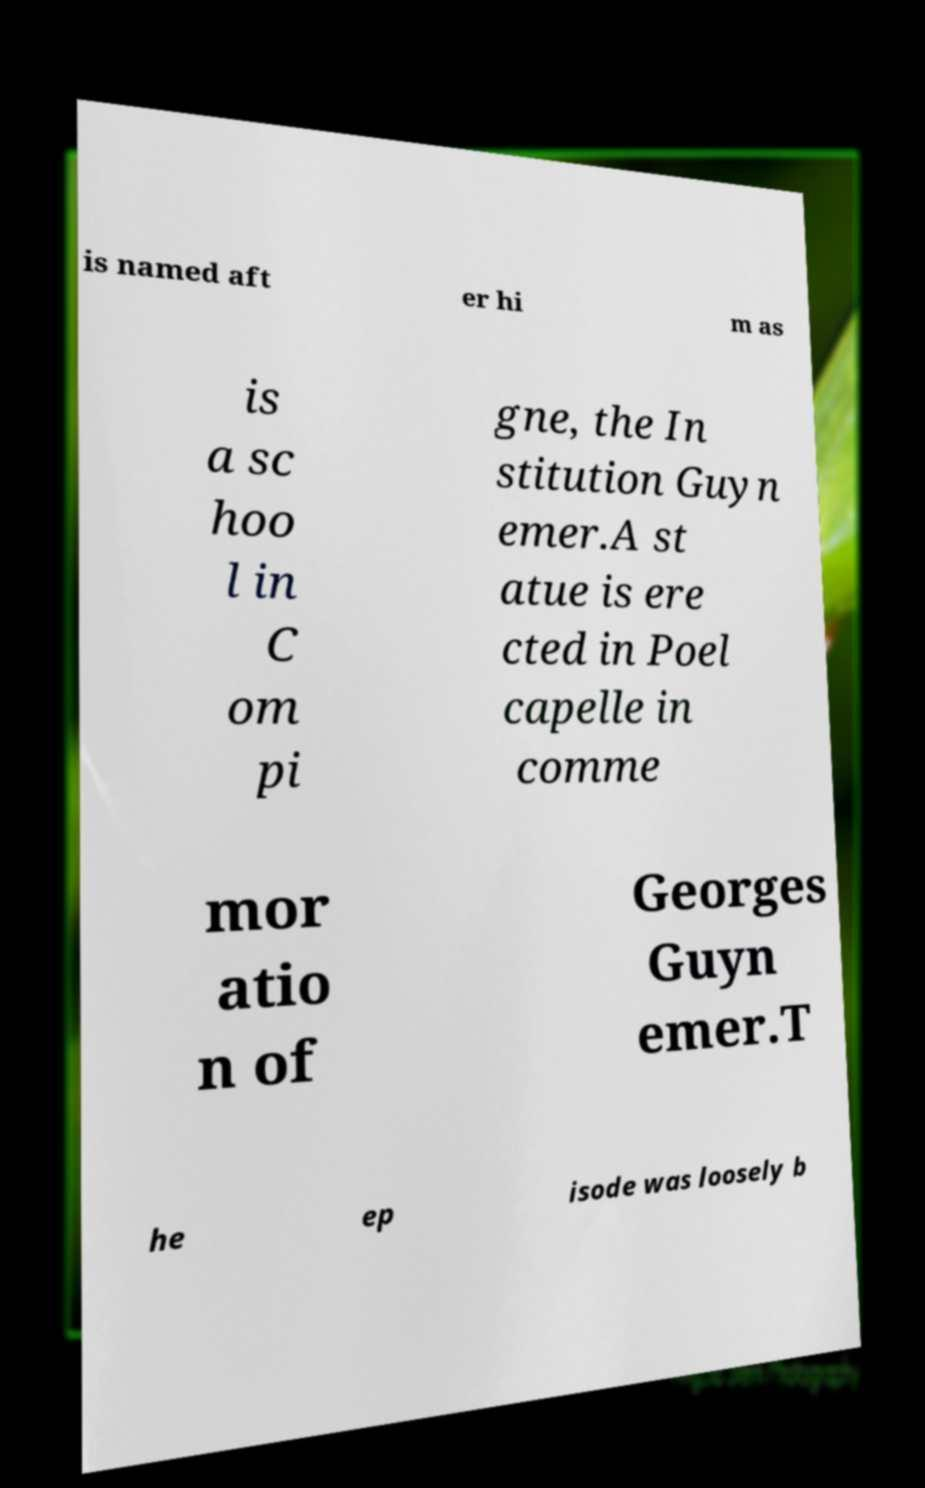Can you accurately transcribe the text from the provided image for me? is named aft er hi m as is a sc hoo l in C om pi gne, the In stitution Guyn emer.A st atue is ere cted in Poel capelle in comme mor atio n of Georges Guyn emer.T he ep isode was loosely b 